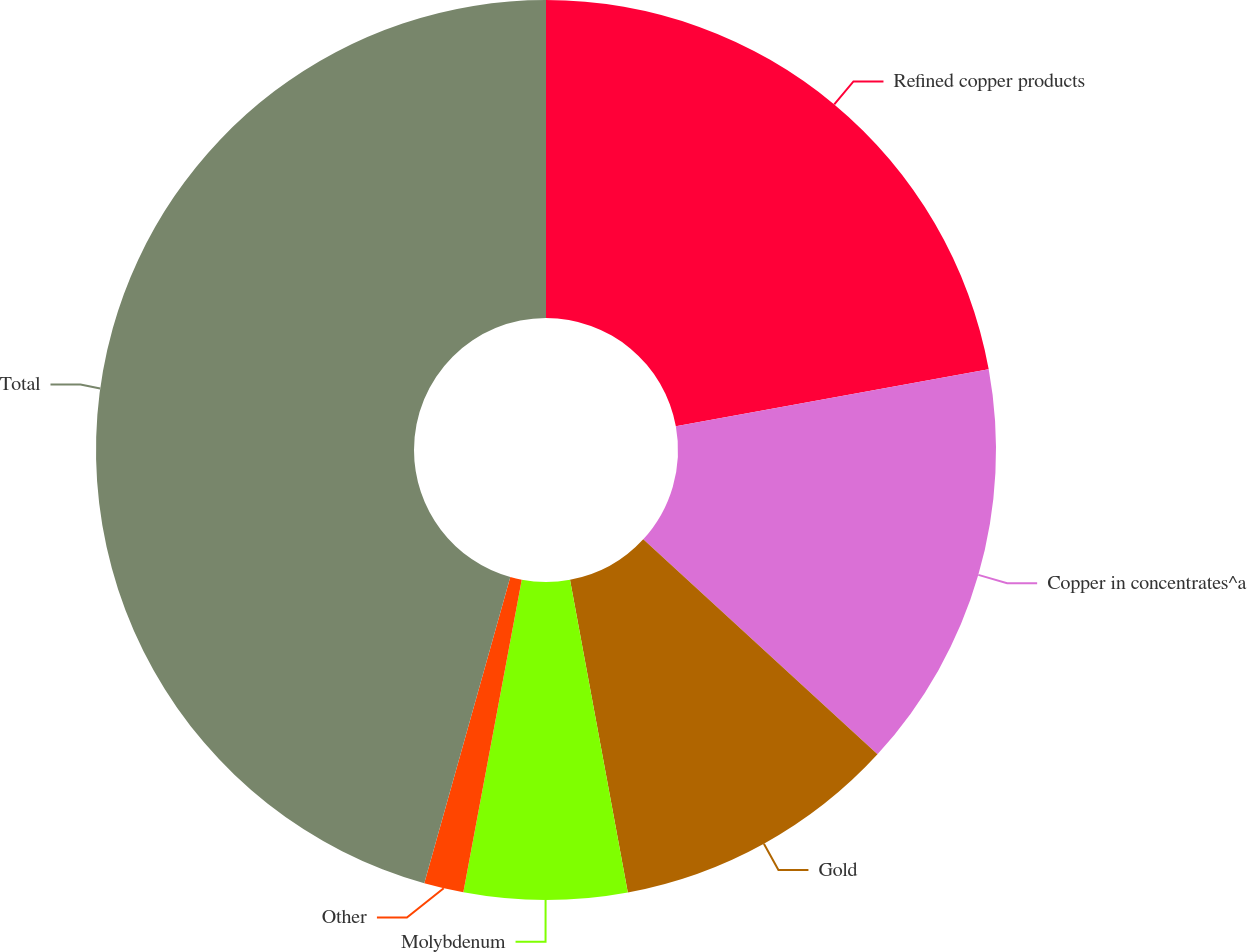Convert chart to OTSL. <chart><loc_0><loc_0><loc_500><loc_500><pie_chart><fcel>Refined copper products<fcel>Copper in concentrates^a<fcel>Gold<fcel>Molybdenum<fcel>Other<fcel>Total<nl><fcel>22.13%<fcel>14.69%<fcel>10.27%<fcel>5.85%<fcel>1.42%<fcel>45.64%<nl></chart> 